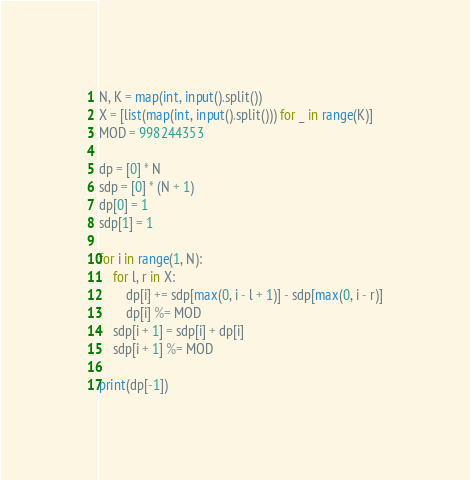Convert code to text. <code><loc_0><loc_0><loc_500><loc_500><_Python_>
N, K = map(int, input().split())
X = [list(map(int, input().split())) for _ in range(K)]
MOD = 998244353

dp = [0] * N
sdp = [0] * (N + 1)
dp[0] = 1
sdp[1] = 1

for i in range(1, N):
    for l, r in X:
        dp[i] += sdp[max(0, i - l + 1)] - sdp[max(0, i - r)]
        dp[i] %= MOD
    sdp[i + 1] = sdp[i] + dp[i]
    sdp[i + 1] %= MOD

print(dp[-1])
</code> 